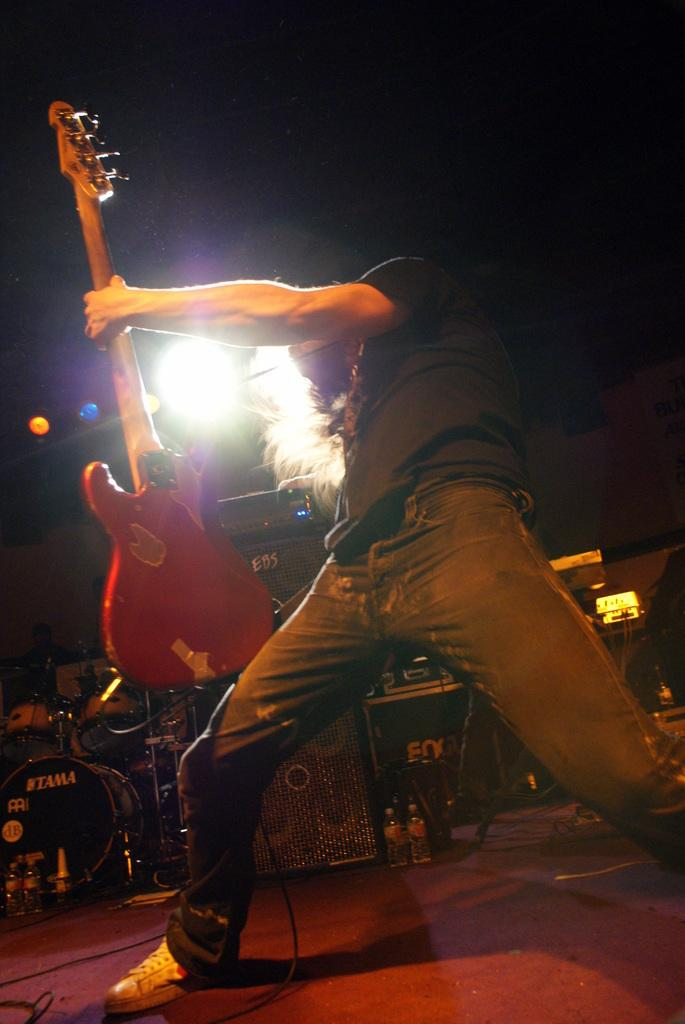What is the person in the image doing? The person is standing and holding a guitar. What else can be seen in the image related to the person's activity? There are focusing lights and musical instruments in the image. Can you describe the speaker in the image? There is a speaker in the image, which is typically used for amplifying sound. What type of needle is being used by the person in the image? There is no needle present in the image; the person is holding a guitar. What act is the person performing in the image? The image does not depict a specific act or performance; it simply shows a person holding a guitar and other related items. 